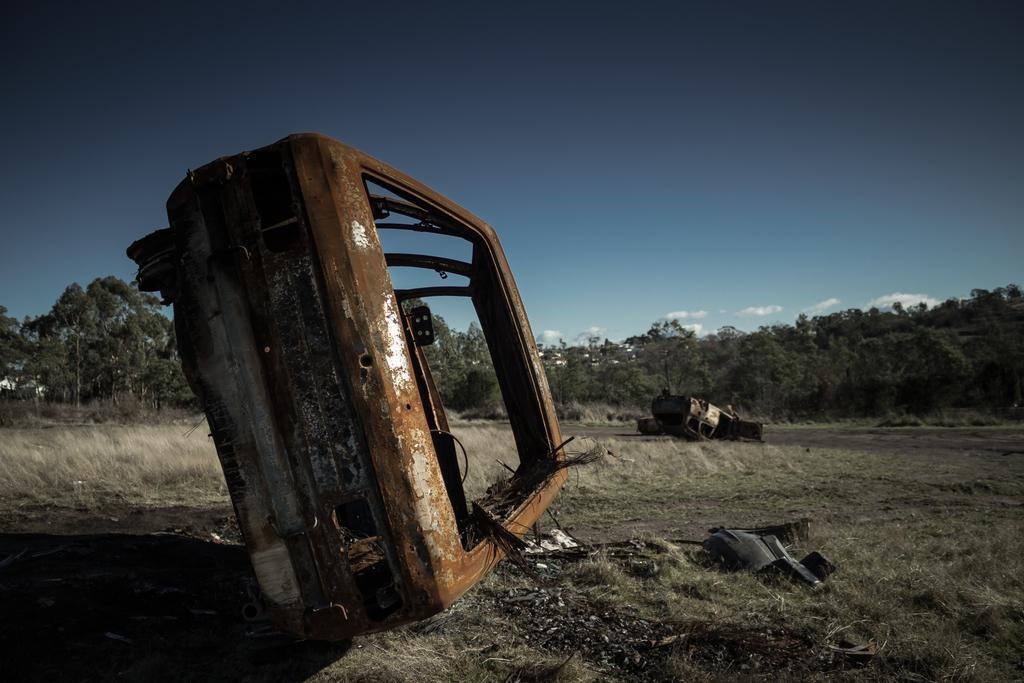Please provide a concise description of this image. On this dried grass we can see scrap cars and an object. Background there are trees and sky. Sky is in blue color. These are clouds. 